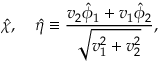<formula> <loc_0><loc_0><loc_500><loc_500>\hat { \chi } , \hat { \eta } \equiv \frac { v _ { 2 } \hat { \phi } _ { 1 } + v _ { 1 } \hat { \phi } _ { 2 } } { \sqrt { v _ { 1 } ^ { 2 } + v _ { 2 } ^ { 2 } } } ,</formula> 